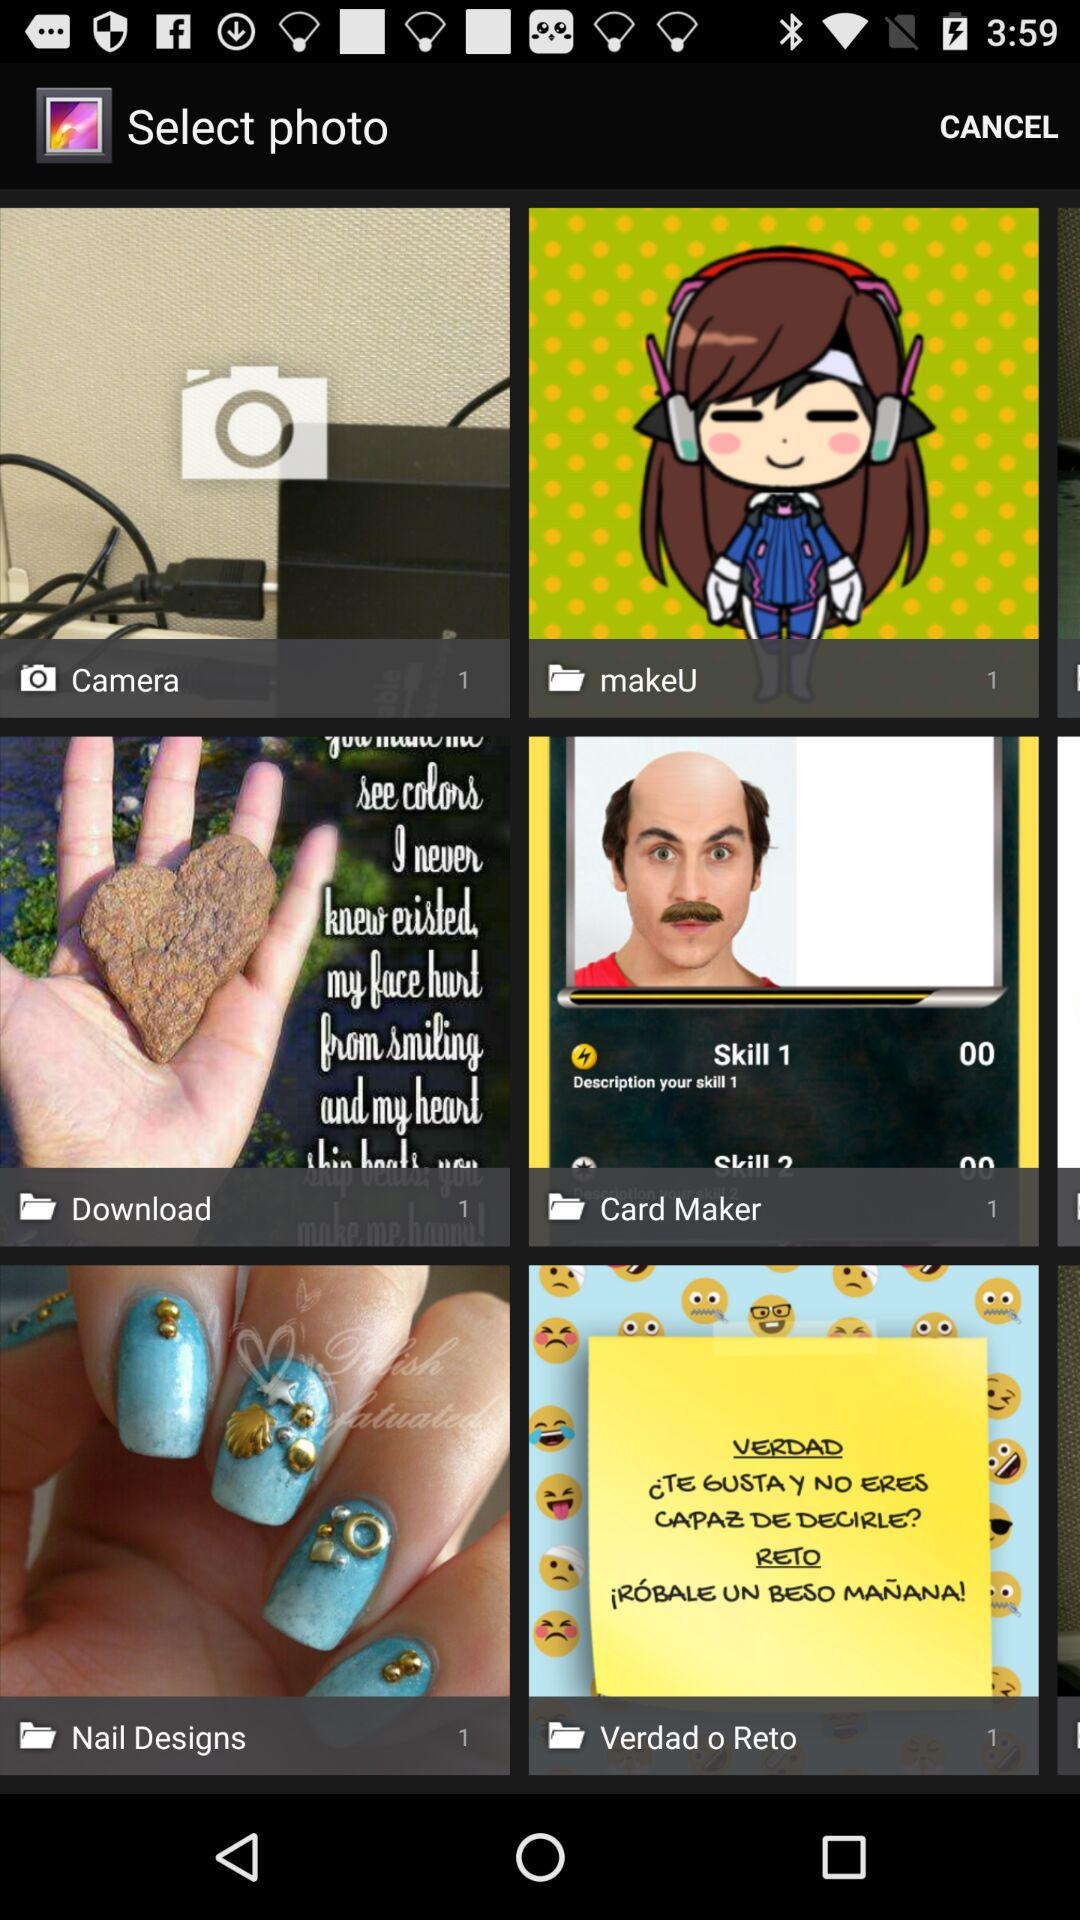How many photographs do you have in "Nail Designs"? There is 1 photograph in "Nail Designs". 